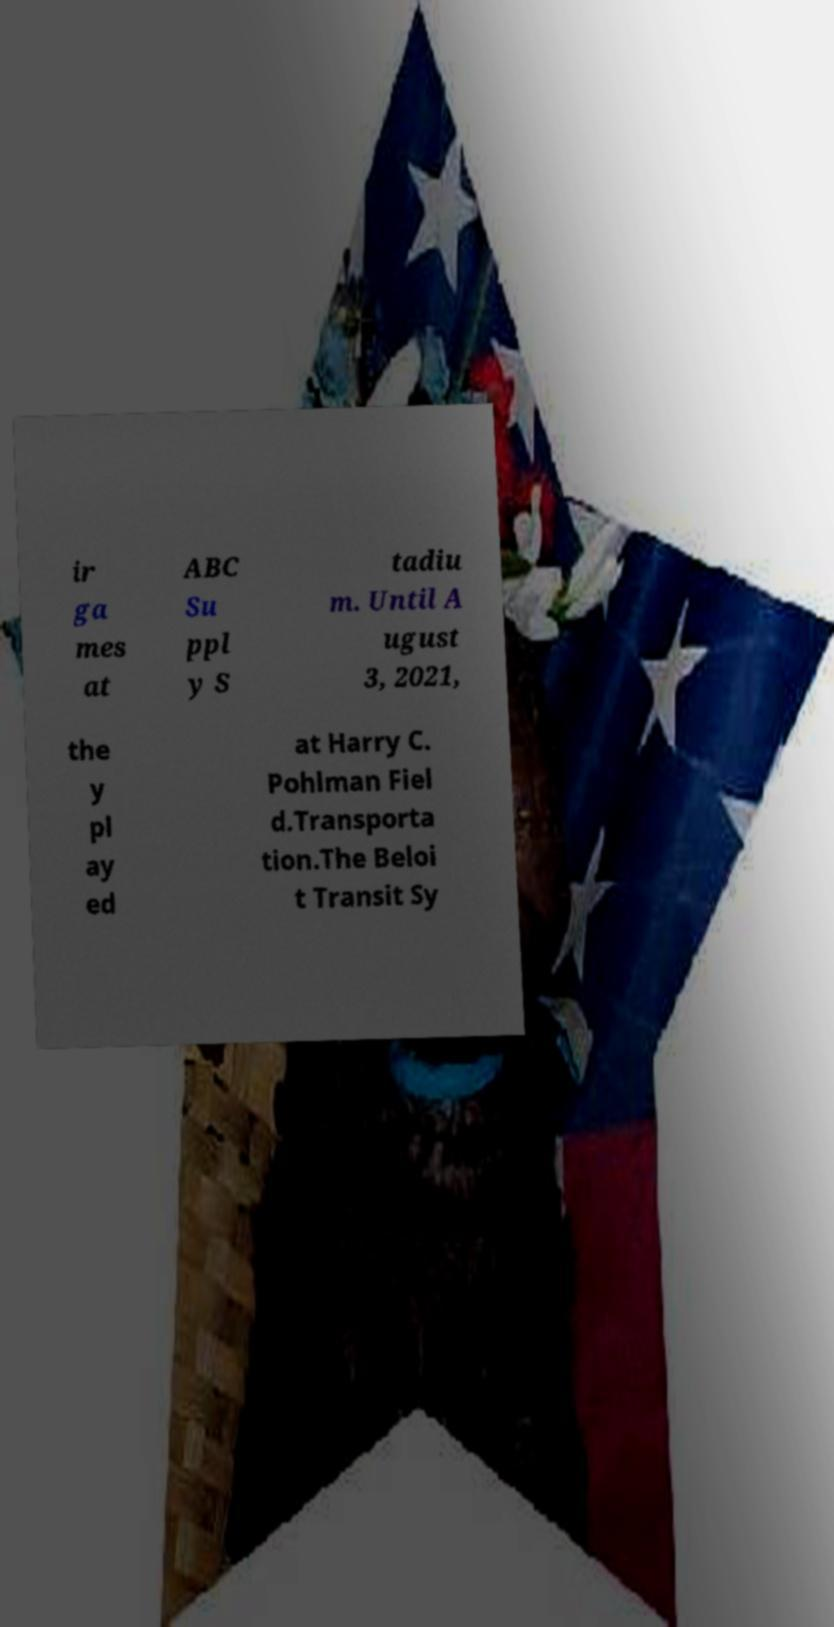Could you extract and type out the text from this image? ir ga mes at ABC Su ppl y S tadiu m. Until A ugust 3, 2021, the y pl ay ed at Harry C. Pohlman Fiel d.Transporta tion.The Beloi t Transit Sy 